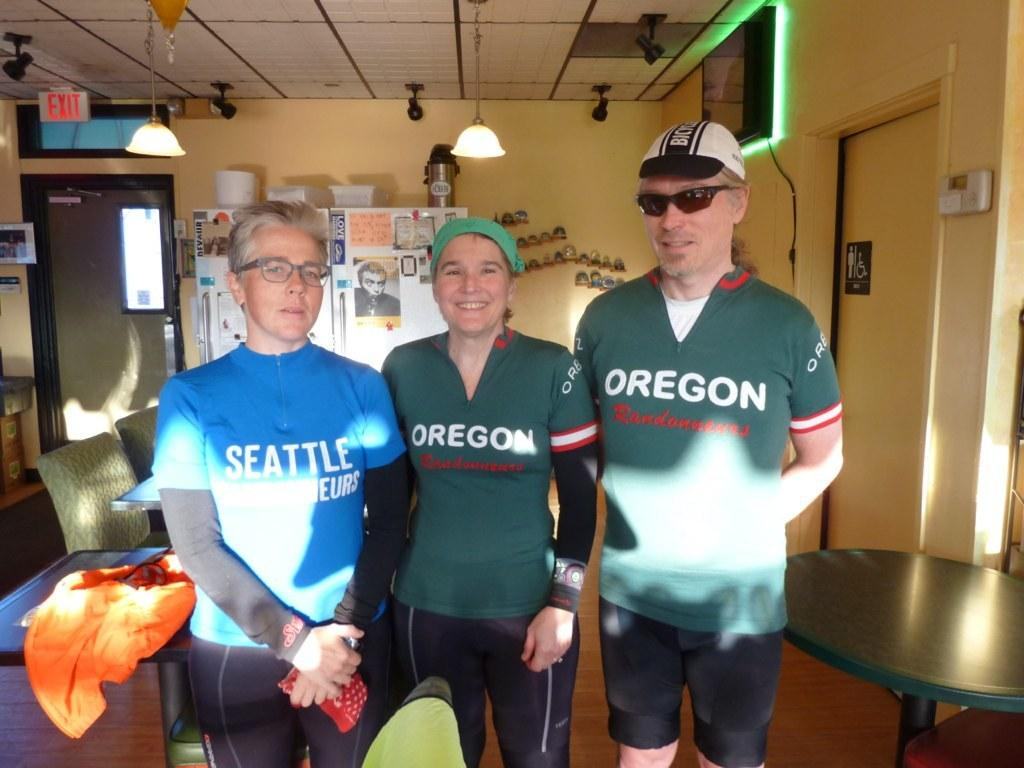<image>
Summarize the visual content of the image. Two people wearing Oregon shirts stand next to a person wearing a Seattle shirt. 